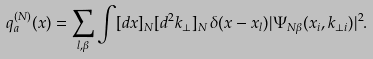<formula> <loc_0><loc_0><loc_500><loc_500>q _ { a } ^ { ( N ) } ( x ) = \sum _ { l , \beta } \int [ d x ] _ { N } [ d ^ { 2 } { k } _ { \perp } ] _ { N } \, \delta ( x - x _ { l } ) | \Psi _ { N \beta } ( x _ { i } , { k } _ { \perp i } ) | ^ { 2 } .</formula> 